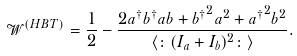<formula> <loc_0><loc_0><loc_500><loc_500>\mathcal { W } ^ { ( H B T ) } = \frac { 1 } { 2 } - \frac { 2 a ^ { \dagger } b ^ { \dagger } a b + { b ^ { \dagger } } ^ { 2 } a ^ { 2 } + { a ^ { \dagger } } ^ { 2 } b ^ { 2 } } { \langle \colon ( I _ { a } + I _ { b } ) ^ { 2 } \colon \rangle } .</formula> 